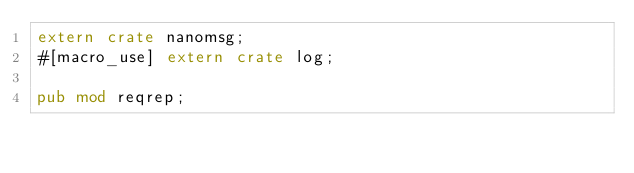Convert code to text. <code><loc_0><loc_0><loc_500><loc_500><_Rust_>extern crate nanomsg;
#[macro_use] extern crate log;

pub mod reqrep;</code> 